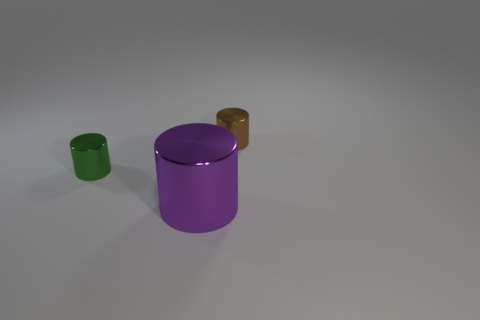How does the lighting in the image affect the mood or perception of these objects? The image has a soft and diffuse lighting that creates soft shadows and reduces harsh contrasts. This lighting gives the objects a calm and neutral presence, highlighting their colors and material qualities without overpowering the observer. It makes the scene appear serene and clean, suitable for a minimalist or contemporary setting. 